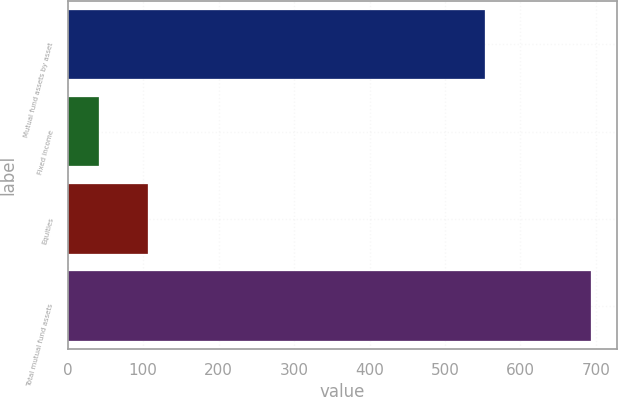Convert chart. <chart><loc_0><loc_0><loc_500><loc_500><bar_chart><fcel>Mutual fund assets by asset<fcel>Fixed income<fcel>Equities<fcel>Total mutual fund assets<nl><fcel>553<fcel>41<fcel>106.2<fcel>693<nl></chart> 